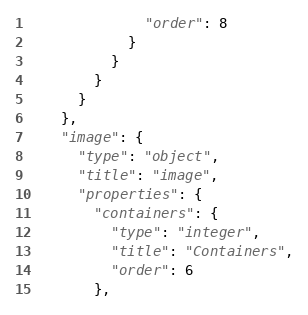<code> <loc_0><loc_0><loc_500><loc_500><_Python_>              "order": 8
            }
          }
        }
      }
    },
    "image": {
      "type": "object",
      "title": "image",
      "properties": {
        "containers": {
          "type": "integer",
          "title": "Containers",
          "order": 6
        },</code> 